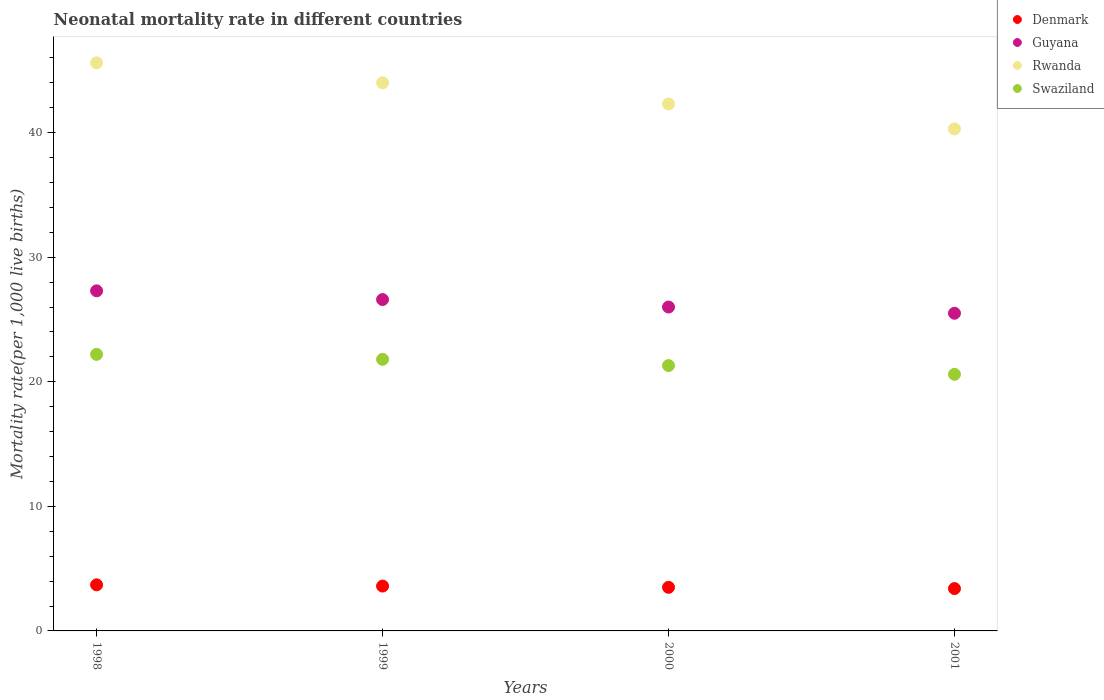How many different coloured dotlines are there?
Ensure brevity in your answer.  4. What is the neonatal mortality rate in Guyana in 1999?
Offer a very short reply. 26.6. In which year was the neonatal mortality rate in Denmark maximum?
Offer a very short reply. 1998. In which year was the neonatal mortality rate in Denmark minimum?
Your response must be concise. 2001. What is the total neonatal mortality rate in Rwanda in the graph?
Make the answer very short. 172.2. What is the difference between the neonatal mortality rate in Swaziland in 1998 and the neonatal mortality rate in Guyana in 2001?
Offer a terse response. -3.3. What is the average neonatal mortality rate in Swaziland per year?
Make the answer very short. 21.48. In the year 2001, what is the difference between the neonatal mortality rate in Rwanda and neonatal mortality rate in Denmark?
Your answer should be compact. 36.9. In how many years, is the neonatal mortality rate in Denmark greater than 26?
Your response must be concise. 0. What is the ratio of the neonatal mortality rate in Denmark in 2000 to that in 2001?
Your answer should be compact. 1.03. What is the difference between the highest and the second highest neonatal mortality rate in Denmark?
Provide a succinct answer. 0.1. What is the difference between the highest and the lowest neonatal mortality rate in Rwanda?
Offer a terse response. 5.3. Is the sum of the neonatal mortality rate in Guyana in 1998 and 1999 greater than the maximum neonatal mortality rate in Rwanda across all years?
Provide a short and direct response. Yes. Is it the case that in every year, the sum of the neonatal mortality rate in Rwanda and neonatal mortality rate in Denmark  is greater than the sum of neonatal mortality rate in Guyana and neonatal mortality rate in Swaziland?
Your answer should be compact. Yes. Is it the case that in every year, the sum of the neonatal mortality rate in Guyana and neonatal mortality rate in Swaziland  is greater than the neonatal mortality rate in Rwanda?
Your answer should be compact. Yes. Is the neonatal mortality rate in Guyana strictly greater than the neonatal mortality rate in Rwanda over the years?
Your response must be concise. No. Is the neonatal mortality rate in Denmark strictly less than the neonatal mortality rate in Swaziland over the years?
Provide a short and direct response. Yes. How many dotlines are there?
Offer a very short reply. 4. How many years are there in the graph?
Ensure brevity in your answer.  4. What is the difference between two consecutive major ticks on the Y-axis?
Provide a succinct answer. 10. Are the values on the major ticks of Y-axis written in scientific E-notation?
Your answer should be very brief. No. Does the graph contain grids?
Offer a terse response. No. Where does the legend appear in the graph?
Your response must be concise. Top right. How many legend labels are there?
Give a very brief answer. 4. How are the legend labels stacked?
Your answer should be very brief. Vertical. What is the title of the graph?
Offer a terse response. Neonatal mortality rate in different countries. What is the label or title of the Y-axis?
Your answer should be very brief. Mortality rate(per 1,0 live births). What is the Mortality rate(per 1,000 live births) of Denmark in 1998?
Give a very brief answer. 3.7. What is the Mortality rate(per 1,000 live births) in Guyana in 1998?
Ensure brevity in your answer.  27.3. What is the Mortality rate(per 1,000 live births) of Rwanda in 1998?
Provide a short and direct response. 45.6. What is the Mortality rate(per 1,000 live births) of Denmark in 1999?
Your response must be concise. 3.6. What is the Mortality rate(per 1,000 live births) in Guyana in 1999?
Your answer should be compact. 26.6. What is the Mortality rate(per 1,000 live births) in Rwanda in 1999?
Provide a succinct answer. 44. What is the Mortality rate(per 1,000 live births) of Swaziland in 1999?
Offer a terse response. 21.8. What is the Mortality rate(per 1,000 live births) of Rwanda in 2000?
Keep it short and to the point. 42.3. What is the Mortality rate(per 1,000 live births) of Swaziland in 2000?
Your answer should be very brief. 21.3. What is the Mortality rate(per 1,000 live births) in Denmark in 2001?
Your response must be concise. 3.4. What is the Mortality rate(per 1,000 live births) of Guyana in 2001?
Offer a terse response. 25.5. What is the Mortality rate(per 1,000 live births) of Rwanda in 2001?
Your response must be concise. 40.3. What is the Mortality rate(per 1,000 live births) in Swaziland in 2001?
Your response must be concise. 20.6. Across all years, what is the maximum Mortality rate(per 1,000 live births) of Denmark?
Make the answer very short. 3.7. Across all years, what is the maximum Mortality rate(per 1,000 live births) of Guyana?
Provide a short and direct response. 27.3. Across all years, what is the maximum Mortality rate(per 1,000 live births) in Rwanda?
Give a very brief answer. 45.6. Across all years, what is the minimum Mortality rate(per 1,000 live births) of Rwanda?
Ensure brevity in your answer.  40.3. Across all years, what is the minimum Mortality rate(per 1,000 live births) of Swaziland?
Make the answer very short. 20.6. What is the total Mortality rate(per 1,000 live births) in Denmark in the graph?
Your answer should be very brief. 14.2. What is the total Mortality rate(per 1,000 live births) in Guyana in the graph?
Ensure brevity in your answer.  105.4. What is the total Mortality rate(per 1,000 live births) of Rwanda in the graph?
Provide a short and direct response. 172.2. What is the total Mortality rate(per 1,000 live births) of Swaziland in the graph?
Make the answer very short. 85.9. What is the difference between the Mortality rate(per 1,000 live births) in Denmark in 1998 and that in 1999?
Your answer should be very brief. 0.1. What is the difference between the Mortality rate(per 1,000 live births) in Guyana in 1998 and that in 1999?
Your answer should be compact. 0.7. What is the difference between the Mortality rate(per 1,000 live births) in Guyana in 1998 and that in 2000?
Provide a succinct answer. 1.3. What is the difference between the Mortality rate(per 1,000 live births) of Rwanda in 1998 and that in 2000?
Your answer should be compact. 3.3. What is the difference between the Mortality rate(per 1,000 live births) of Swaziland in 1998 and that in 2000?
Your answer should be very brief. 0.9. What is the difference between the Mortality rate(per 1,000 live births) of Denmark in 1998 and that in 2001?
Give a very brief answer. 0.3. What is the difference between the Mortality rate(per 1,000 live births) in Rwanda in 1998 and that in 2001?
Make the answer very short. 5.3. What is the difference between the Mortality rate(per 1,000 live births) in Denmark in 1999 and that in 2000?
Make the answer very short. 0.1. What is the difference between the Mortality rate(per 1,000 live births) of Swaziland in 1999 and that in 2000?
Your answer should be compact. 0.5. What is the difference between the Mortality rate(per 1,000 live births) of Rwanda in 1999 and that in 2001?
Provide a succinct answer. 3.7. What is the difference between the Mortality rate(per 1,000 live births) in Denmark in 2000 and that in 2001?
Provide a short and direct response. 0.1. What is the difference between the Mortality rate(per 1,000 live births) of Guyana in 2000 and that in 2001?
Offer a very short reply. 0.5. What is the difference between the Mortality rate(per 1,000 live births) in Rwanda in 2000 and that in 2001?
Keep it short and to the point. 2. What is the difference between the Mortality rate(per 1,000 live births) in Denmark in 1998 and the Mortality rate(per 1,000 live births) in Guyana in 1999?
Your response must be concise. -22.9. What is the difference between the Mortality rate(per 1,000 live births) of Denmark in 1998 and the Mortality rate(per 1,000 live births) of Rwanda in 1999?
Your answer should be very brief. -40.3. What is the difference between the Mortality rate(per 1,000 live births) of Denmark in 1998 and the Mortality rate(per 1,000 live births) of Swaziland in 1999?
Keep it short and to the point. -18.1. What is the difference between the Mortality rate(per 1,000 live births) of Guyana in 1998 and the Mortality rate(per 1,000 live births) of Rwanda in 1999?
Your answer should be compact. -16.7. What is the difference between the Mortality rate(per 1,000 live births) of Guyana in 1998 and the Mortality rate(per 1,000 live births) of Swaziland in 1999?
Ensure brevity in your answer.  5.5. What is the difference between the Mortality rate(per 1,000 live births) of Rwanda in 1998 and the Mortality rate(per 1,000 live births) of Swaziland in 1999?
Offer a very short reply. 23.8. What is the difference between the Mortality rate(per 1,000 live births) of Denmark in 1998 and the Mortality rate(per 1,000 live births) of Guyana in 2000?
Provide a short and direct response. -22.3. What is the difference between the Mortality rate(per 1,000 live births) in Denmark in 1998 and the Mortality rate(per 1,000 live births) in Rwanda in 2000?
Ensure brevity in your answer.  -38.6. What is the difference between the Mortality rate(per 1,000 live births) of Denmark in 1998 and the Mortality rate(per 1,000 live births) of Swaziland in 2000?
Keep it short and to the point. -17.6. What is the difference between the Mortality rate(per 1,000 live births) in Guyana in 1998 and the Mortality rate(per 1,000 live births) in Rwanda in 2000?
Ensure brevity in your answer.  -15. What is the difference between the Mortality rate(per 1,000 live births) in Guyana in 1998 and the Mortality rate(per 1,000 live births) in Swaziland in 2000?
Your answer should be very brief. 6. What is the difference between the Mortality rate(per 1,000 live births) of Rwanda in 1998 and the Mortality rate(per 1,000 live births) of Swaziland in 2000?
Make the answer very short. 24.3. What is the difference between the Mortality rate(per 1,000 live births) in Denmark in 1998 and the Mortality rate(per 1,000 live births) in Guyana in 2001?
Offer a terse response. -21.8. What is the difference between the Mortality rate(per 1,000 live births) in Denmark in 1998 and the Mortality rate(per 1,000 live births) in Rwanda in 2001?
Give a very brief answer. -36.6. What is the difference between the Mortality rate(per 1,000 live births) in Denmark in 1998 and the Mortality rate(per 1,000 live births) in Swaziland in 2001?
Provide a succinct answer. -16.9. What is the difference between the Mortality rate(per 1,000 live births) of Guyana in 1998 and the Mortality rate(per 1,000 live births) of Rwanda in 2001?
Your answer should be compact. -13. What is the difference between the Mortality rate(per 1,000 live births) in Denmark in 1999 and the Mortality rate(per 1,000 live births) in Guyana in 2000?
Make the answer very short. -22.4. What is the difference between the Mortality rate(per 1,000 live births) in Denmark in 1999 and the Mortality rate(per 1,000 live births) in Rwanda in 2000?
Your answer should be compact. -38.7. What is the difference between the Mortality rate(per 1,000 live births) of Denmark in 1999 and the Mortality rate(per 1,000 live births) of Swaziland in 2000?
Provide a short and direct response. -17.7. What is the difference between the Mortality rate(per 1,000 live births) in Guyana in 1999 and the Mortality rate(per 1,000 live births) in Rwanda in 2000?
Keep it short and to the point. -15.7. What is the difference between the Mortality rate(per 1,000 live births) of Guyana in 1999 and the Mortality rate(per 1,000 live births) of Swaziland in 2000?
Provide a succinct answer. 5.3. What is the difference between the Mortality rate(per 1,000 live births) of Rwanda in 1999 and the Mortality rate(per 1,000 live births) of Swaziland in 2000?
Your answer should be compact. 22.7. What is the difference between the Mortality rate(per 1,000 live births) in Denmark in 1999 and the Mortality rate(per 1,000 live births) in Guyana in 2001?
Provide a succinct answer. -21.9. What is the difference between the Mortality rate(per 1,000 live births) of Denmark in 1999 and the Mortality rate(per 1,000 live births) of Rwanda in 2001?
Keep it short and to the point. -36.7. What is the difference between the Mortality rate(per 1,000 live births) in Denmark in 1999 and the Mortality rate(per 1,000 live births) in Swaziland in 2001?
Your answer should be compact. -17. What is the difference between the Mortality rate(per 1,000 live births) of Guyana in 1999 and the Mortality rate(per 1,000 live births) of Rwanda in 2001?
Your response must be concise. -13.7. What is the difference between the Mortality rate(per 1,000 live births) in Guyana in 1999 and the Mortality rate(per 1,000 live births) in Swaziland in 2001?
Give a very brief answer. 6. What is the difference between the Mortality rate(per 1,000 live births) of Rwanda in 1999 and the Mortality rate(per 1,000 live births) of Swaziland in 2001?
Provide a short and direct response. 23.4. What is the difference between the Mortality rate(per 1,000 live births) in Denmark in 2000 and the Mortality rate(per 1,000 live births) in Rwanda in 2001?
Your answer should be compact. -36.8. What is the difference between the Mortality rate(per 1,000 live births) in Denmark in 2000 and the Mortality rate(per 1,000 live births) in Swaziland in 2001?
Make the answer very short. -17.1. What is the difference between the Mortality rate(per 1,000 live births) in Guyana in 2000 and the Mortality rate(per 1,000 live births) in Rwanda in 2001?
Provide a short and direct response. -14.3. What is the difference between the Mortality rate(per 1,000 live births) of Rwanda in 2000 and the Mortality rate(per 1,000 live births) of Swaziland in 2001?
Make the answer very short. 21.7. What is the average Mortality rate(per 1,000 live births) in Denmark per year?
Provide a succinct answer. 3.55. What is the average Mortality rate(per 1,000 live births) of Guyana per year?
Keep it short and to the point. 26.35. What is the average Mortality rate(per 1,000 live births) of Rwanda per year?
Your response must be concise. 43.05. What is the average Mortality rate(per 1,000 live births) in Swaziland per year?
Ensure brevity in your answer.  21.48. In the year 1998, what is the difference between the Mortality rate(per 1,000 live births) of Denmark and Mortality rate(per 1,000 live births) of Guyana?
Offer a very short reply. -23.6. In the year 1998, what is the difference between the Mortality rate(per 1,000 live births) in Denmark and Mortality rate(per 1,000 live births) in Rwanda?
Give a very brief answer. -41.9. In the year 1998, what is the difference between the Mortality rate(per 1,000 live births) in Denmark and Mortality rate(per 1,000 live births) in Swaziland?
Your response must be concise. -18.5. In the year 1998, what is the difference between the Mortality rate(per 1,000 live births) in Guyana and Mortality rate(per 1,000 live births) in Rwanda?
Your answer should be very brief. -18.3. In the year 1998, what is the difference between the Mortality rate(per 1,000 live births) in Rwanda and Mortality rate(per 1,000 live births) in Swaziland?
Give a very brief answer. 23.4. In the year 1999, what is the difference between the Mortality rate(per 1,000 live births) in Denmark and Mortality rate(per 1,000 live births) in Rwanda?
Keep it short and to the point. -40.4. In the year 1999, what is the difference between the Mortality rate(per 1,000 live births) in Denmark and Mortality rate(per 1,000 live births) in Swaziland?
Your answer should be compact. -18.2. In the year 1999, what is the difference between the Mortality rate(per 1,000 live births) in Guyana and Mortality rate(per 1,000 live births) in Rwanda?
Your answer should be compact. -17.4. In the year 2000, what is the difference between the Mortality rate(per 1,000 live births) in Denmark and Mortality rate(per 1,000 live births) in Guyana?
Keep it short and to the point. -22.5. In the year 2000, what is the difference between the Mortality rate(per 1,000 live births) in Denmark and Mortality rate(per 1,000 live births) in Rwanda?
Keep it short and to the point. -38.8. In the year 2000, what is the difference between the Mortality rate(per 1,000 live births) of Denmark and Mortality rate(per 1,000 live births) of Swaziland?
Your response must be concise. -17.8. In the year 2000, what is the difference between the Mortality rate(per 1,000 live births) of Guyana and Mortality rate(per 1,000 live births) of Rwanda?
Give a very brief answer. -16.3. In the year 2000, what is the difference between the Mortality rate(per 1,000 live births) of Guyana and Mortality rate(per 1,000 live births) of Swaziland?
Your answer should be compact. 4.7. In the year 2000, what is the difference between the Mortality rate(per 1,000 live births) of Rwanda and Mortality rate(per 1,000 live births) of Swaziland?
Keep it short and to the point. 21. In the year 2001, what is the difference between the Mortality rate(per 1,000 live births) of Denmark and Mortality rate(per 1,000 live births) of Guyana?
Offer a very short reply. -22.1. In the year 2001, what is the difference between the Mortality rate(per 1,000 live births) of Denmark and Mortality rate(per 1,000 live births) of Rwanda?
Keep it short and to the point. -36.9. In the year 2001, what is the difference between the Mortality rate(per 1,000 live births) of Denmark and Mortality rate(per 1,000 live births) of Swaziland?
Ensure brevity in your answer.  -17.2. In the year 2001, what is the difference between the Mortality rate(per 1,000 live births) of Guyana and Mortality rate(per 1,000 live births) of Rwanda?
Keep it short and to the point. -14.8. In the year 2001, what is the difference between the Mortality rate(per 1,000 live births) of Guyana and Mortality rate(per 1,000 live births) of Swaziland?
Offer a terse response. 4.9. In the year 2001, what is the difference between the Mortality rate(per 1,000 live births) of Rwanda and Mortality rate(per 1,000 live births) of Swaziland?
Offer a terse response. 19.7. What is the ratio of the Mortality rate(per 1,000 live births) in Denmark in 1998 to that in 1999?
Provide a succinct answer. 1.03. What is the ratio of the Mortality rate(per 1,000 live births) of Guyana in 1998 to that in 1999?
Your response must be concise. 1.03. What is the ratio of the Mortality rate(per 1,000 live births) of Rwanda in 1998 to that in 1999?
Make the answer very short. 1.04. What is the ratio of the Mortality rate(per 1,000 live births) in Swaziland in 1998 to that in 1999?
Provide a short and direct response. 1.02. What is the ratio of the Mortality rate(per 1,000 live births) in Denmark in 1998 to that in 2000?
Your answer should be very brief. 1.06. What is the ratio of the Mortality rate(per 1,000 live births) of Rwanda in 1998 to that in 2000?
Offer a very short reply. 1.08. What is the ratio of the Mortality rate(per 1,000 live births) in Swaziland in 1998 to that in 2000?
Make the answer very short. 1.04. What is the ratio of the Mortality rate(per 1,000 live births) of Denmark in 1998 to that in 2001?
Make the answer very short. 1.09. What is the ratio of the Mortality rate(per 1,000 live births) of Guyana in 1998 to that in 2001?
Offer a very short reply. 1.07. What is the ratio of the Mortality rate(per 1,000 live births) in Rwanda in 1998 to that in 2001?
Offer a very short reply. 1.13. What is the ratio of the Mortality rate(per 1,000 live births) of Swaziland in 1998 to that in 2001?
Your answer should be compact. 1.08. What is the ratio of the Mortality rate(per 1,000 live births) in Denmark in 1999 to that in 2000?
Make the answer very short. 1.03. What is the ratio of the Mortality rate(per 1,000 live births) of Guyana in 1999 to that in 2000?
Offer a very short reply. 1.02. What is the ratio of the Mortality rate(per 1,000 live births) of Rwanda in 1999 to that in 2000?
Offer a very short reply. 1.04. What is the ratio of the Mortality rate(per 1,000 live births) in Swaziland in 1999 to that in 2000?
Give a very brief answer. 1.02. What is the ratio of the Mortality rate(per 1,000 live births) in Denmark in 1999 to that in 2001?
Your answer should be very brief. 1.06. What is the ratio of the Mortality rate(per 1,000 live births) of Guyana in 1999 to that in 2001?
Your answer should be very brief. 1.04. What is the ratio of the Mortality rate(per 1,000 live births) of Rwanda in 1999 to that in 2001?
Provide a succinct answer. 1.09. What is the ratio of the Mortality rate(per 1,000 live births) of Swaziland in 1999 to that in 2001?
Offer a terse response. 1.06. What is the ratio of the Mortality rate(per 1,000 live births) in Denmark in 2000 to that in 2001?
Offer a very short reply. 1.03. What is the ratio of the Mortality rate(per 1,000 live births) of Guyana in 2000 to that in 2001?
Keep it short and to the point. 1.02. What is the ratio of the Mortality rate(per 1,000 live births) of Rwanda in 2000 to that in 2001?
Give a very brief answer. 1.05. What is the ratio of the Mortality rate(per 1,000 live births) of Swaziland in 2000 to that in 2001?
Ensure brevity in your answer.  1.03. What is the difference between the highest and the second highest Mortality rate(per 1,000 live births) of Denmark?
Make the answer very short. 0.1. What is the difference between the highest and the second highest Mortality rate(per 1,000 live births) in Swaziland?
Offer a terse response. 0.4. What is the difference between the highest and the lowest Mortality rate(per 1,000 live births) of Denmark?
Your response must be concise. 0.3. What is the difference between the highest and the lowest Mortality rate(per 1,000 live births) in Rwanda?
Keep it short and to the point. 5.3. What is the difference between the highest and the lowest Mortality rate(per 1,000 live births) in Swaziland?
Keep it short and to the point. 1.6. 